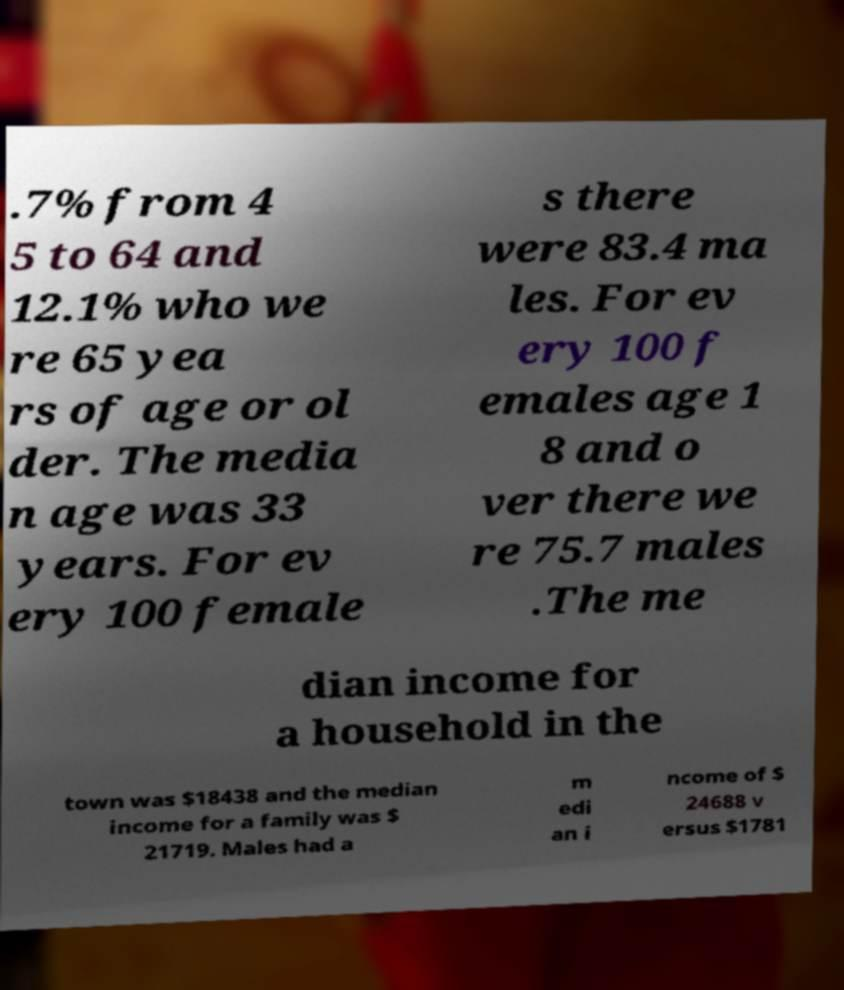Could you assist in decoding the text presented in this image and type it out clearly? .7% from 4 5 to 64 and 12.1% who we re 65 yea rs of age or ol der. The media n age was 33 years. For ev ery 100 female s there were 83.4 ma les. For ev ery 100 f emales age 1 8 and o ver there we re 75.7 males .The me dian income for a household in the town was $18438 and the median income for a family was $ 21719. Males had a m edi an i ncome of $ 24688 v ersus $1781 